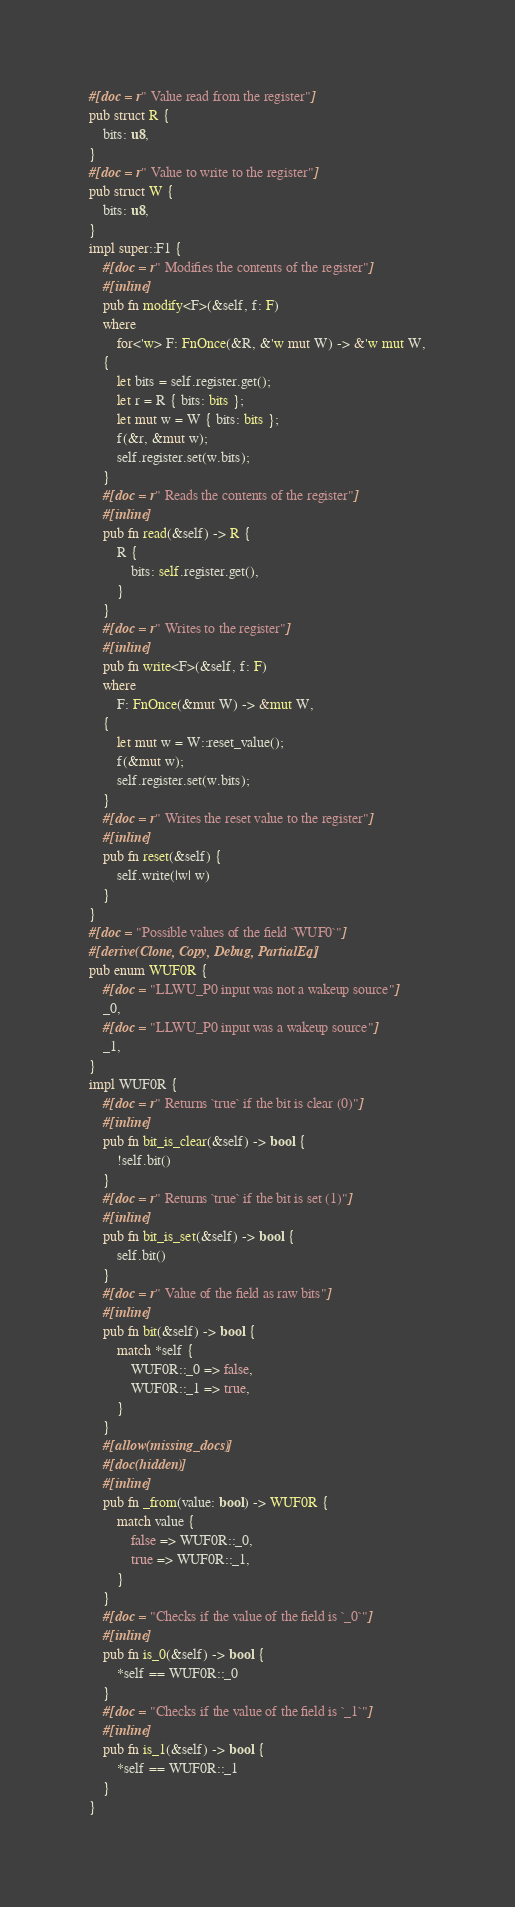<code> <loc_0><loc_0><loc_500><loc_500><_Rust_>#[doc = r" Value read from the register"]
pub struct R {
    bits: u8,
}
#[doc = r" Value to write to the register"]
pub struct W {
    bits: u8,
}
impl super::F1 {
    #[doc = r" Modifies the contents of the register"]
    #[inline]
    pub fn modify<F>(&self, f: F)
    where
        for<'w> F: FnOnce(&R, &'w mut W) -> &'w mut W,
    {
        let bits = self.register.get();
        let r = R { bits: bits };
        let mut w = W { bits: bits };
        f(&r, &mut w);
        self.register.set(w.bits);
    }
    #[doc = r" Reads the contents of the register"]
    #[inline]
    pub fn read(&self) -> R {
        R {
            bits: self.register.get(),
        }
    }
    #[doc = r" Writes to the register"]
    #[inline]
    pub fn write<F>(&self, f: F)
    where
        F: FnOnce(&mut W) -> &mut W,
    {
        let mut w = W::reset_value();
        f(&mut w);
        self.register.set(w.bits);
    }
    #[doc = r" Writes the reset value to the register"]
    #[inline]
    pub fn reset(&self) {
        self.write(|w| w)
    }
}
#[doc = "Possible values of the field `WUF0`"]
#[derive(Clone, Copy, Debug, PartialEq)]
pub enum WUF0R {
    #[doc = "LLWU_P0 input was not a wakeup source"]
    _0,
    #[doc = "LLWU_P0 input was a wakeup source"]
    _1,
}
impl WUF0R {
    #[doc = r" Returns `true` if the bit is clear (0)"]
    #[inline]
    pub fn bit_is_clear(&self) -> bool {
        !self.bit()
    }
    #[doc = r" Returns `true` if the bit is set (1)"]
    #[inline]
    pub fn bit_is_set(&self) -> bool {
        self.bit()
    }
    #[doc = r" Value of the field as raw bits"]
    #[inline]
    pub fn bit(&self) -> bool {
        match *self {
            WUF0R::_0 => false,
            WUF0R::_1 => true,
        }
    }
    #[allow(missing_docs)]
    #[doc(hidden)]
    #[inline]
    pub fn _from(value: bool) -> WUF0R {
        match value {
            false => WUF0R::_0,
            true => WUF0R::_1,
        }
    }
    #[doc = "Checks if the value of the field is `_0`"]
    #[inline]
    pub fn is_0(&self) -> bool {
        *self == WUF0R::_0
    }
    #[doc = "Checks if the value of the field is `_1`"]
    #[inline]
    pub fn is_1(&self) -> bool {
        *self == WUF0R::_1
    }
}</code> 